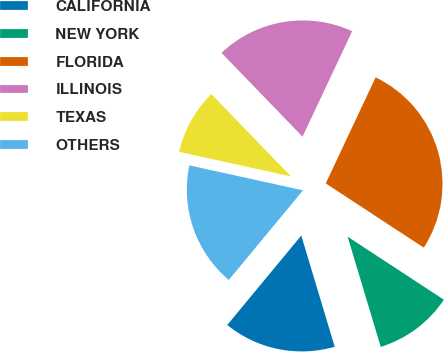Convert chart to OTSL. <chart><loc_0><loc_0><loc_500><loc_500><pie_chart><fcel>CALIFORNIA<fcel>NEW YORK<fcel>FLORIDA<fcel>ILLINOIS<fcel>TEXAS<fcel>OTHERS<nl><fcel>15.65%<fcel>11.12%<fcel>27.23%<fcel>19.23%<fcel>9.33%<fcel>17.44%<nl></chart> 